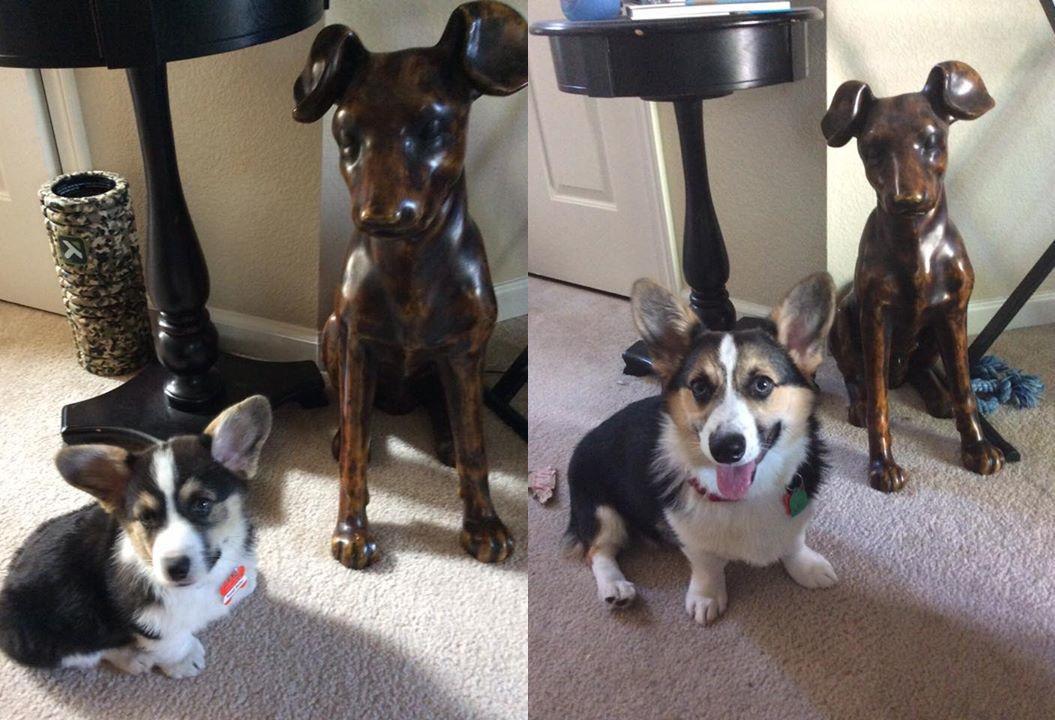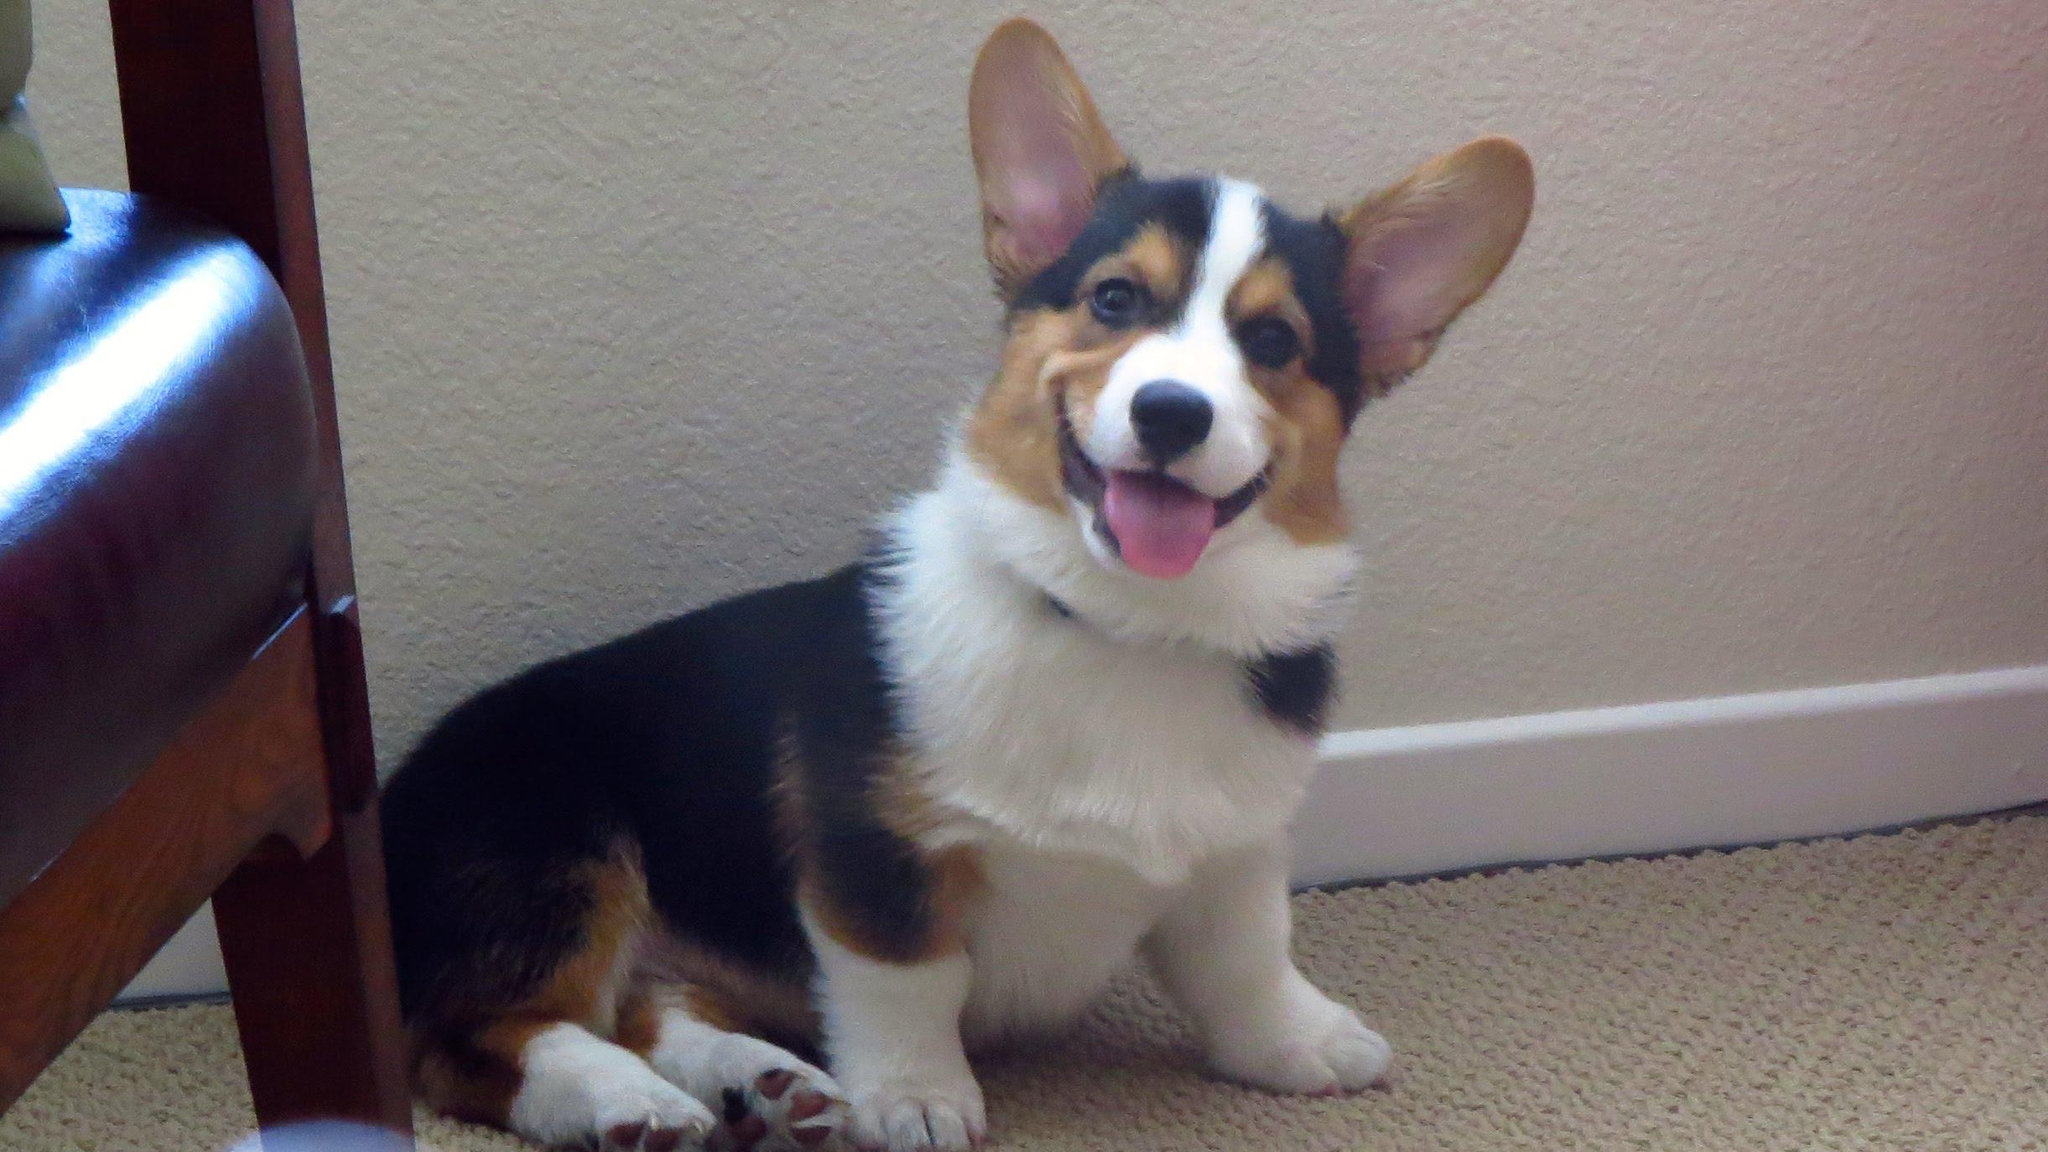The first image is the image on the left, the second image is the image on the right. Assess this claim about the two images: "At least one dog's tongue is hanging out of its mouth.". Correct or not? Answer yes or no. Yes. The first image is the image on the left, the second image is the image on the right. Assess this claim about the two images: "An image shows a corgi dog without a leash, standing on all fours and looking upward at the camera.". Correct or not? Answer yes or no. No. 